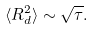<formula> <loc_0><loc_0><loc_500><loc_500>\langle R _ { d } ^ { 2 } \rangle \sim { \sqrt { \tau } } .</formula> 